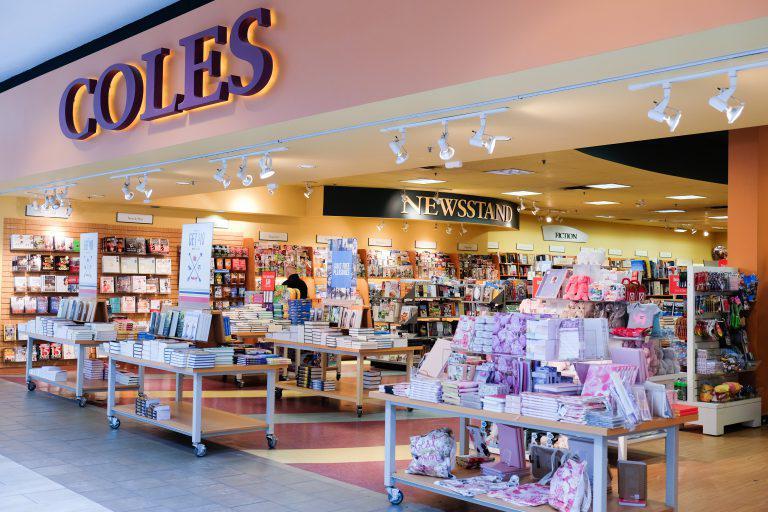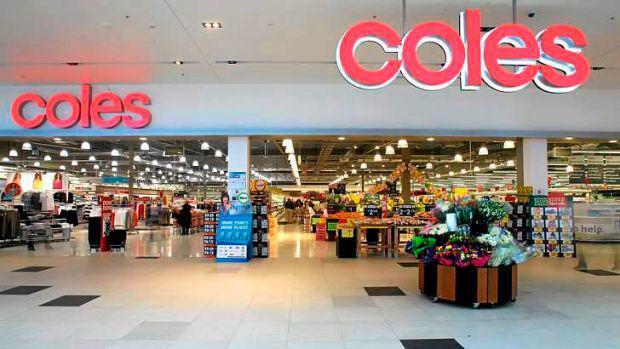The first image is the image on the left, the second image is the image on the right. For the images shown, is this caption "At least one person is standing near the entrance of the store in the image on the left." true? Answer yes or no. No. 